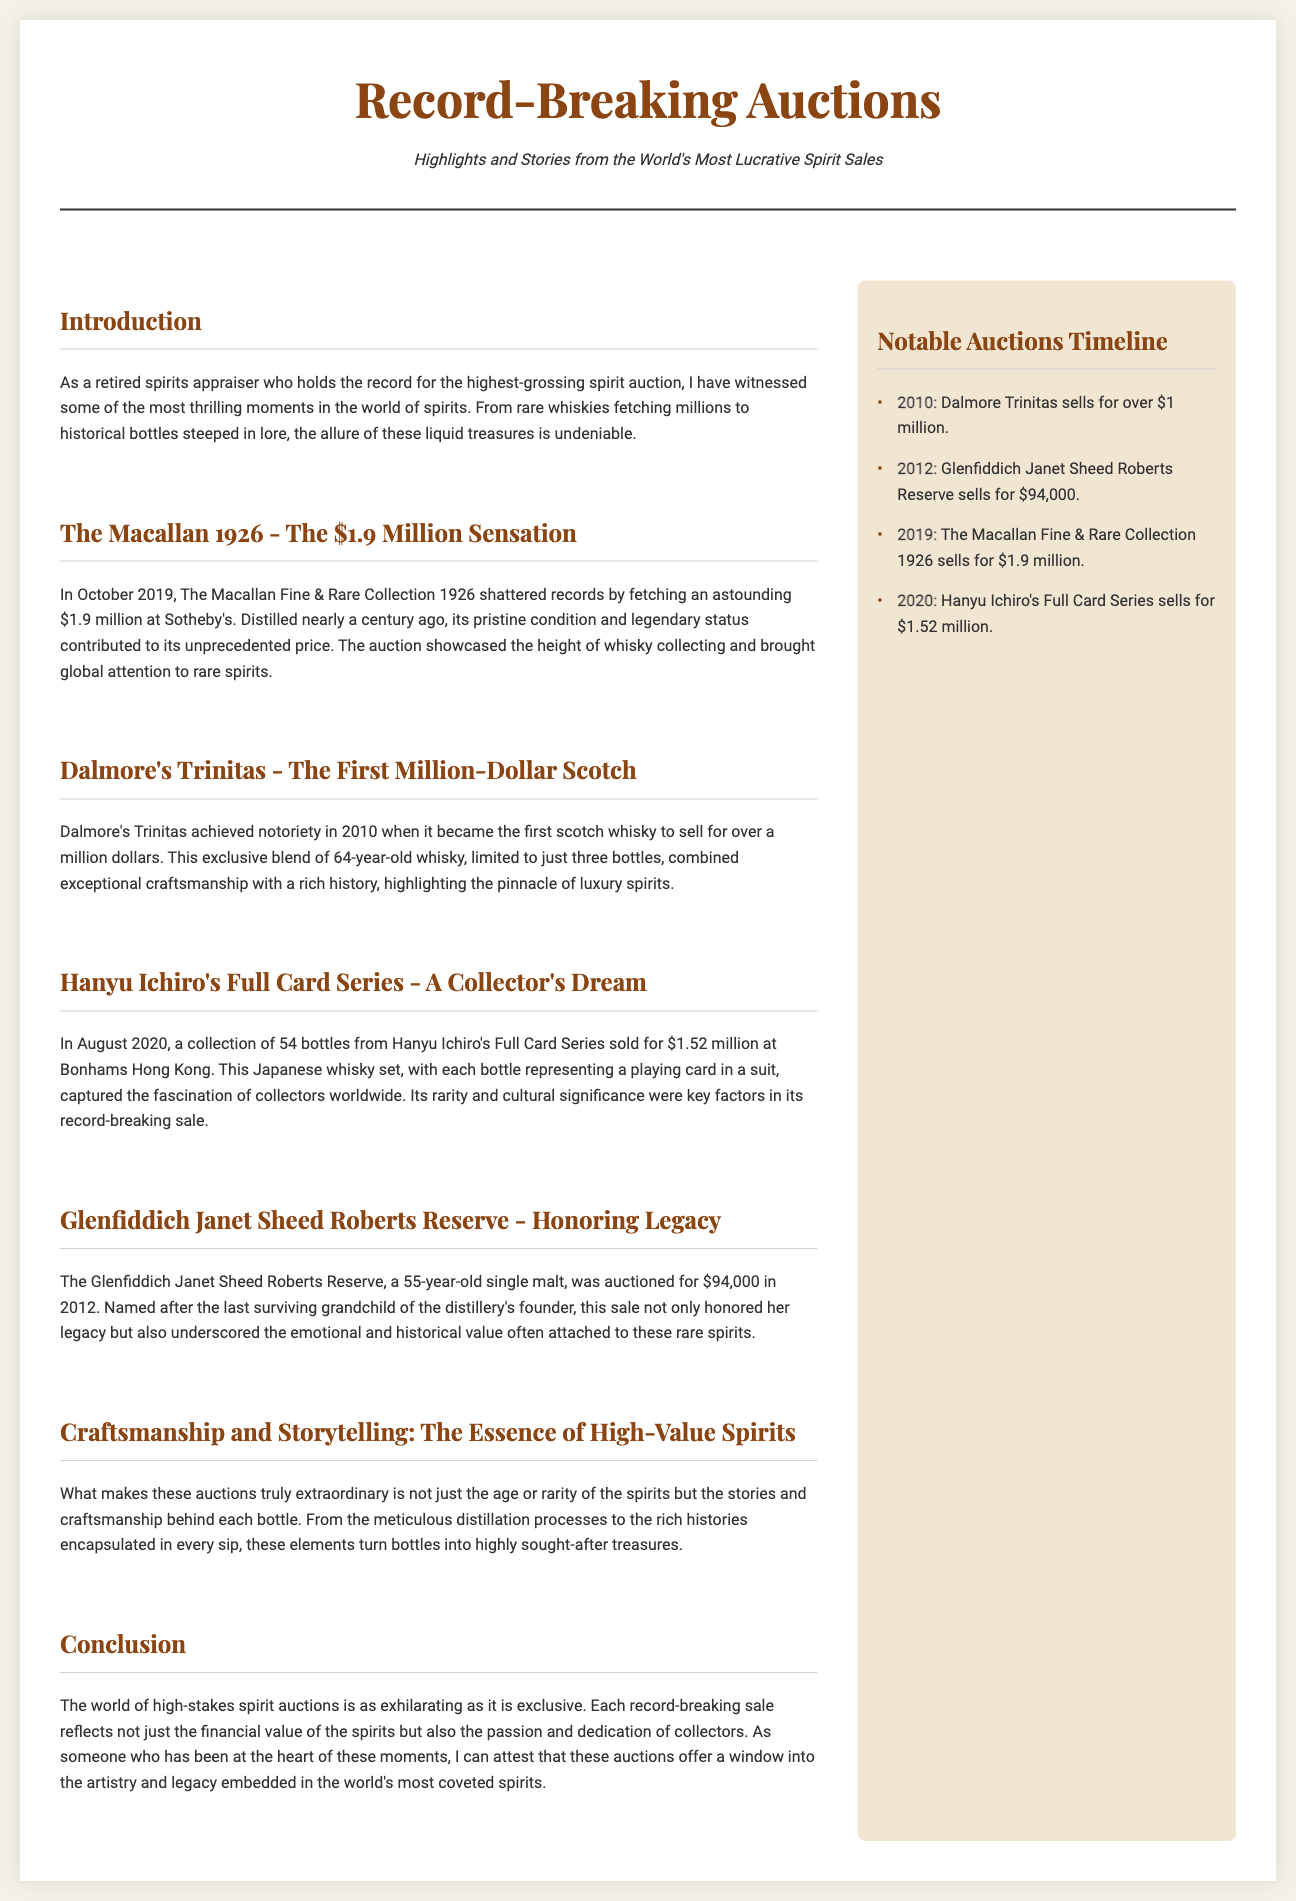what was the auction price of The Macallan 1926? The auction price for The Macallan 1926 was reported in the document as $1.9 million.
Answer: $1.9 million what year did Dalmore's Trinitas sell for over a million dollars? The document states that Dalmore's Trinitas achieved notoriety in 2010, becoming the first scotch whisky to sell for over a million dollars.
Answer: 2010 how many bottles are in Hanyu Ichiro's Full Card Series? The document mentions that there are 54 bottles in Hanyu Ichiro's Full Card Series.
Answer: 54 which whisky was auctioned for $94,000 in 2012? The Glenfiddich Janet Sheed Roberts Reserve was auctioned for $94,000 in 2012 according to the document.
Answer: Glenfiddich Janet Sheed Roberts Reserve what is a key factor that contributes to the value of high-value spirits? The document mentions that stories and craftsmanship behind each bottle contribute to the value of high-value spirits.
Answer: Stories and craftsmanship which auction mentioned in the timeline occurred in 2020? The document states that Hanyu Ichiro's Full Card Series sold for $1.52 million in 2020.
Answer: Hanyu Ichiro's Full Card Series what overarching theme does the conclusion emphasize regarding spirit auctions? The conclusion emphasizes the passion and dedication of collectors as a theme in high-stakes spirit auctions.
Answer: Passion and dedication of collectors who is the last surviving grandchild of the Glenfiddich distillery founder? The document refers to Janet Sheed Roberts as the last surviving grandchild of the distillery's founder.
Answer: Janet Sheed Roberts 